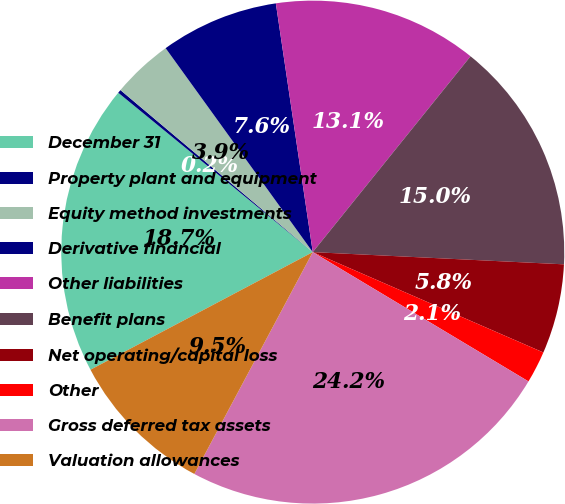Convert chart. <chart><loc_0><loc_0><loc_500><loc_500><pie_chart><fcel>December 31<fcel>Property plant and equipment<fcel>Equity method investments<fcel>Derivative financial<fcel>Other liabilities<fcel>Benefit plans<fcel>Net operating/capital loss<fcel>Other<fcel>Gross deferred tax assets<fcel>Valuation allowances<nl><fcel>18.67%<fcel>0.22%<fcel>3.91%<fcel>7.6%<fcel>13.14%<fcel>14.98%<fcel>5.76%<fcel>2.06%<fcel>24.21%<fcel>9.45%<nl></chart> 